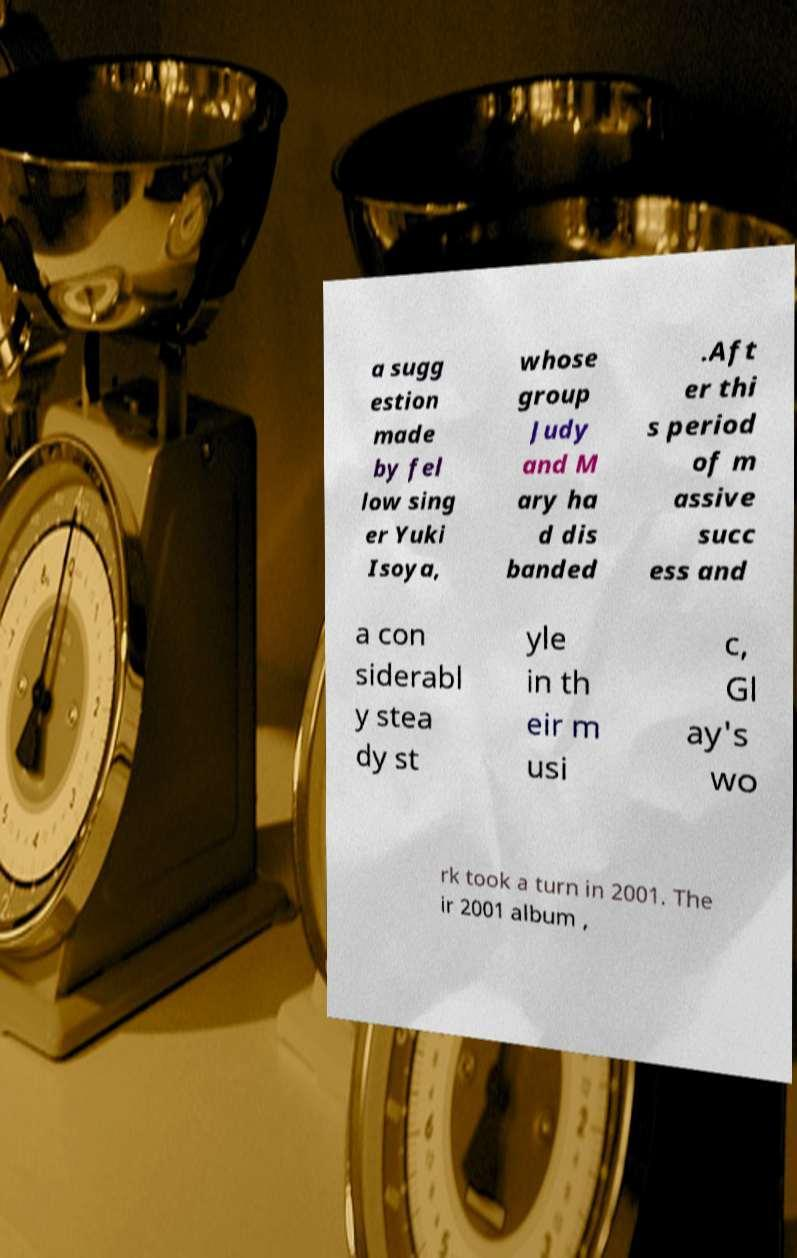Can you read and provide the text displayed in the image?This photo seems to have some interesting text. Can you extract and type it out for me? a sugg estion made by fel low sing er Yuki Isoya, whose group Judy and M ary ha d dis banded .Aft er thi s period of m assive succ ess and a con siderabl y stea dy st yle in th eir m usi c, Gl ay's wo rk took a turn in 2001. The ir 2001 album , 